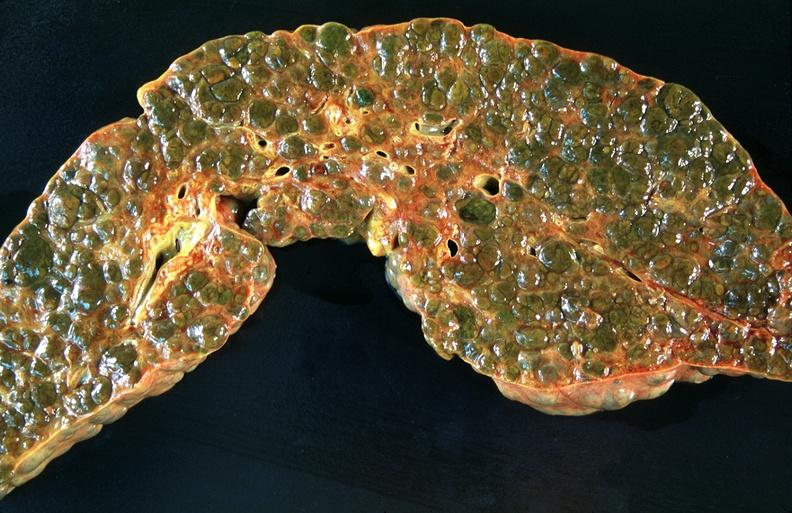what is present?
Answer the question using a single word or phrase. Hepatobiliary 